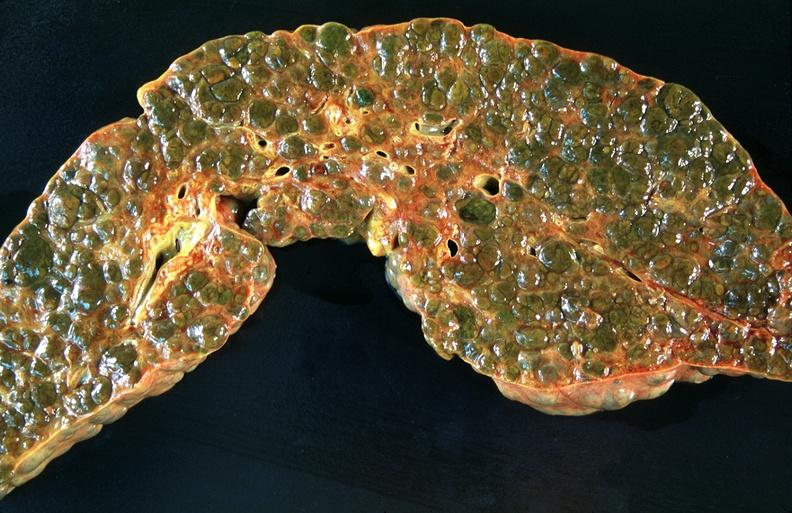what is present?
Answer the question using a single word or phrase. Hepatobiliary 